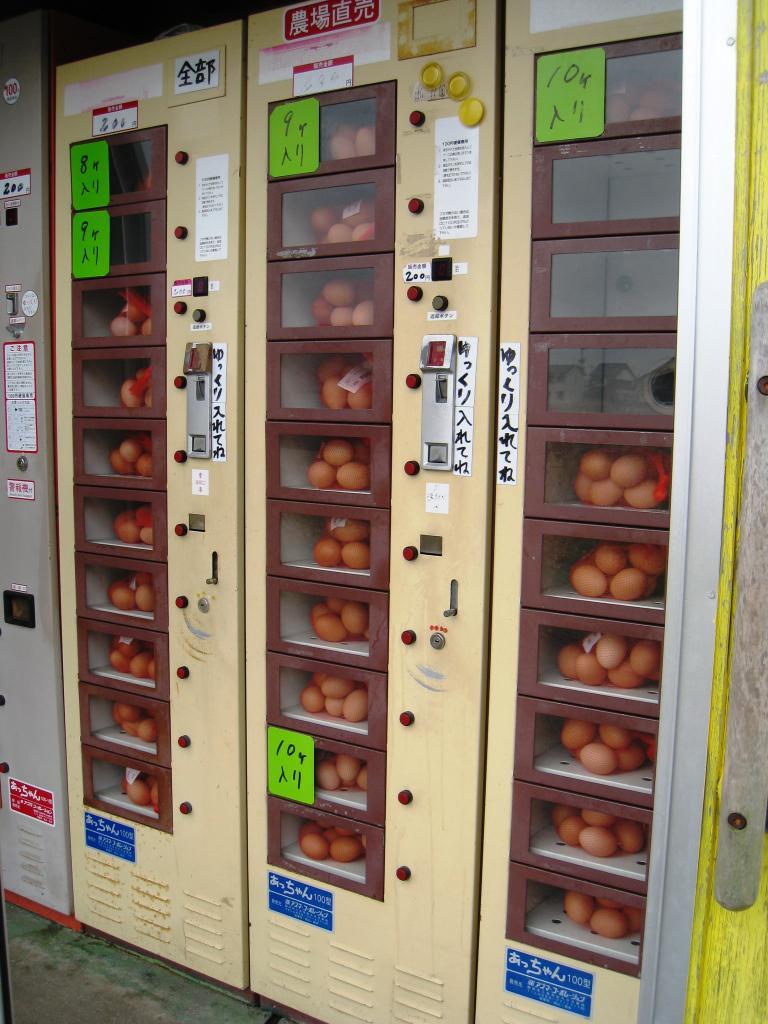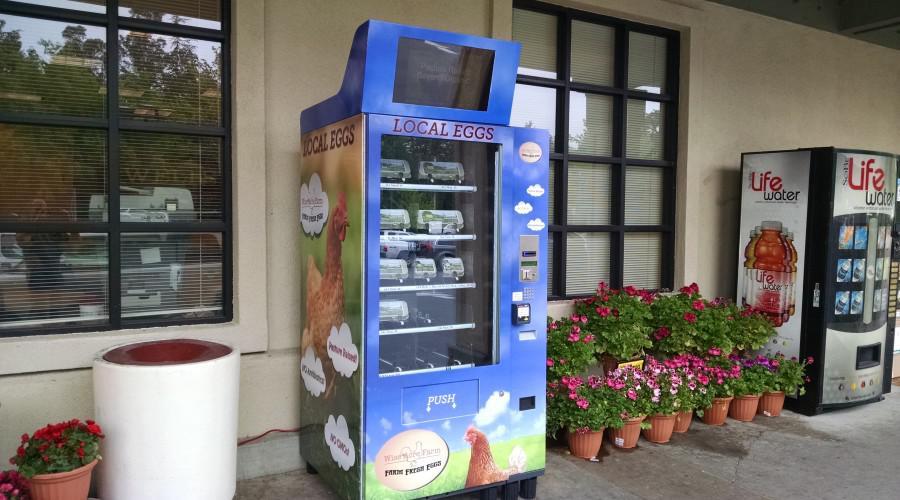The first image is the image on the left, the second image is the image on the right. Assess this claim about the two images: "The vending machine in the left image sells eggs, and does not have visible chickens in it.". Correct or not? Answer yes or no. Yes. The first image is the image on the left, the second image is the image on the right. For the images displayed, is the sentence "There is at least one red vending machine in full view that accepts cash to dispense the food or drink." factually correct? Answer yes or no. No. 